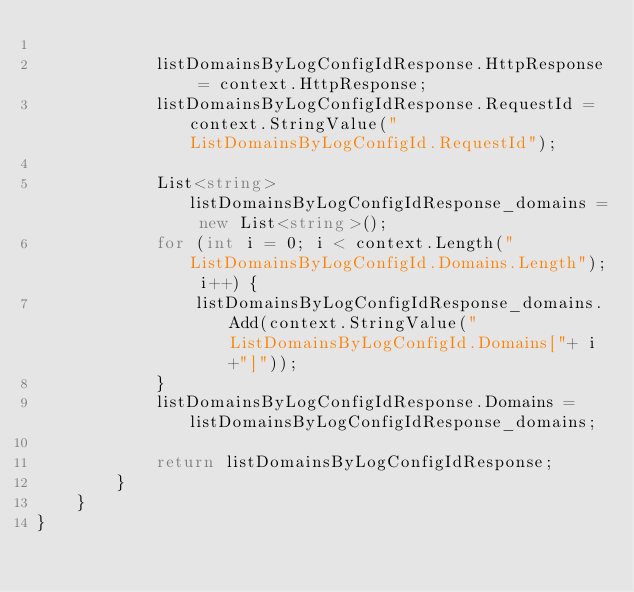Convert code to text. <code><loc_0><loc_0><loc_500><loc_500><_C#_>
			listDomainsByLogConfigIdResponse.HttpResponse = context.HttpResponse;
			listDomainsByLogConfigIdResponse.RequestId = context.StringValue("ListDomainsByLogConfigId.RequestId");

			List<string> listDomainsByLogConfigIdResponse_domains = new List<string>();
			for (int i = 0; i < context.Length("ListDomainsByLogConfigId.Domains.Length"); i++) {
				listDomainsByLogConfigIdResponse_domains.Add(context.StringValue("ListDomainsByLogConfigId.Domains["+ i +"]"));
			}
			listDomainsByLogConfigIdResponse.Domains = listDomainsByLogConfigIdResponse_domains;
        
			return listDomainsByLogConfigIdResponse;
        }
    }
}</code> 